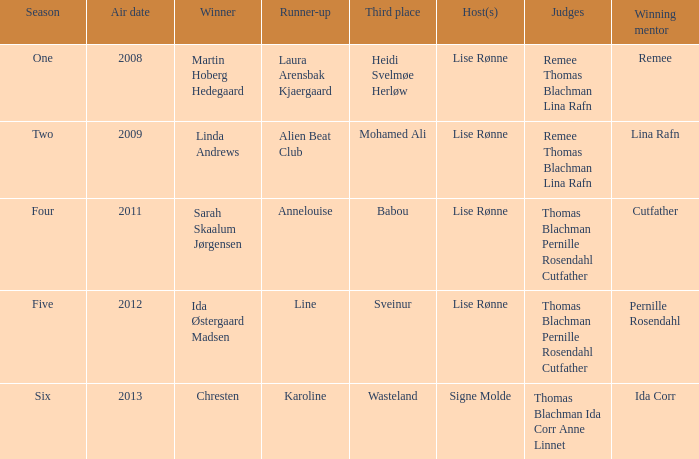During which season did ida corr achieve victory? Six. 